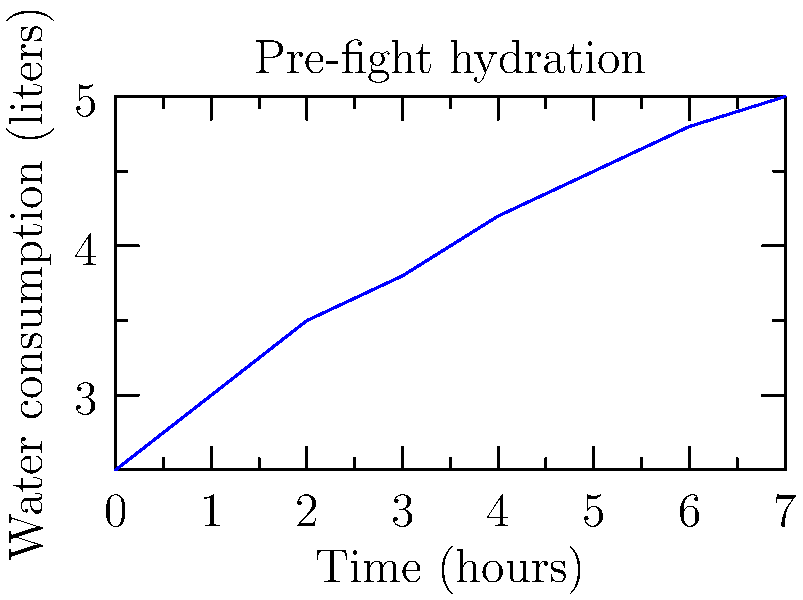Given the line graph showing water consumption over time during pre-fight preparation, calculate the average rate of water consumption per hour between the 2-hour and 6-hour marks. To calculate the average rate of water consumption per hour between the 2-hour and 6-hour marks:

1. Identify the water consumption at 2 hours: $3.5$ liters
2. Identify the water consumption at 6 hours: $4.8$ liters
3. Calculate the total change in water consumption:
   $\Delta W = 4.8 - 3.5 = 1.3$ liters
4. Calculate the time interval:
   $\Delta T = 6 - 2 = 4$ hours
5. Use the formula for average rate:
   Average rate $= \frac{\Delta W}{\Delta T} = \frac{1.3 \text{ liters}}{4 \text{ hours}} = 0.325$ liters/hour

Therefore, the average rate of water consumption between the 2-hour and 6-hour marks is $0.325$ liters per hour.
Answer: $0.325$ liters/hour 